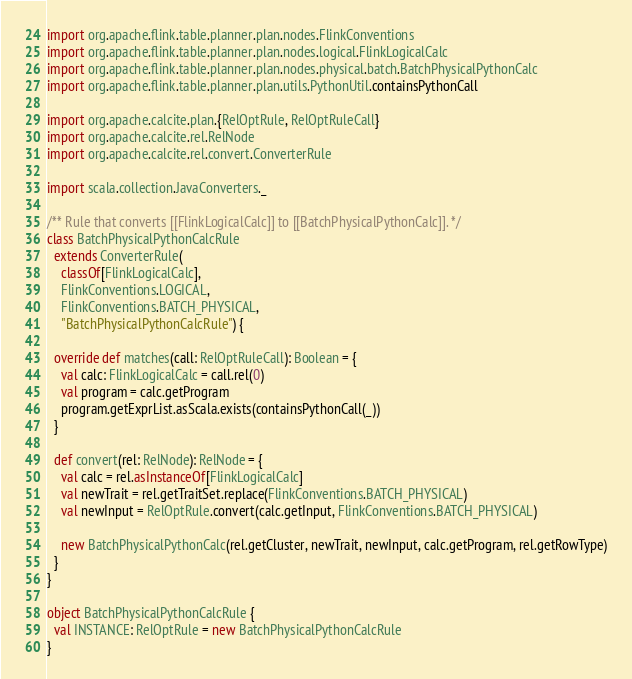Convert code to text. <code><loc_0><loc_0><loc_500><loc_500><_Scala_>import org.apache.flink.table.planner.plan.nodes.FlinkConventions
import org.apache.flink.table.planner.plan.nodes.logical.FlinkLogicalCalc
import org.apache.flink.table.planner.plan.nodes.physical.batch.BatchPhysicalPythonCalc
import org.apache.flink.table.planner.plan.utils.PythonUtil.containsPythonCall

import org.apache.calcite.plan.{RelOptRule, RelOptRuleCall}
import org.apache.calcite.rel.RelNode
import org.apache.calcite.rel.convert.ConverterRule

import scala.collection.JavaConverters._

/** Rule that converts [[FlinkLogicalCalc]] to [[BatchPhysicalPythonCalc]]. */
class BatchPhysicalPythonCalcRule
  extends ConverterRule(
    classOf[FlinkLogicalCalc],
    FlinkConventions.LOGICAL,
    FlinkConventions.BATCH_PHYSICAL,
    "BatchPhysicalPythonCalcRule") {

  override def matches(call: RelOptRuleCall): Boolean = {
    val calc: FlinkLogicalCalc = call.rel(0)
    val program = calc.getProgram
    program.getExprList.asScala.exists(containsPythonCall(_))
  }

  def convert(rel: RelNode): RelNode = {
    val calc = rel.asInstanceOf[FlinkLogicalCalc]
    val newTrait = rel.getTraitSet.replace(FlinkConventions.BATCH_PHYSICAL)
    val newInput = RelOptRule.convert(calc.getInput, FlinkConventions.BATCH_PHYSICAL)

    new BatchPhysicalPythonCalc(rel.getCluster, newTrait, newInput, calc.getProgram, rel.getRowType)
  }
}

object BatchPhysicalPythonCalcRule {
  val INSTANCE: RelOptRule = new BatchPhysicalPythonCalcRule
}
</code> 